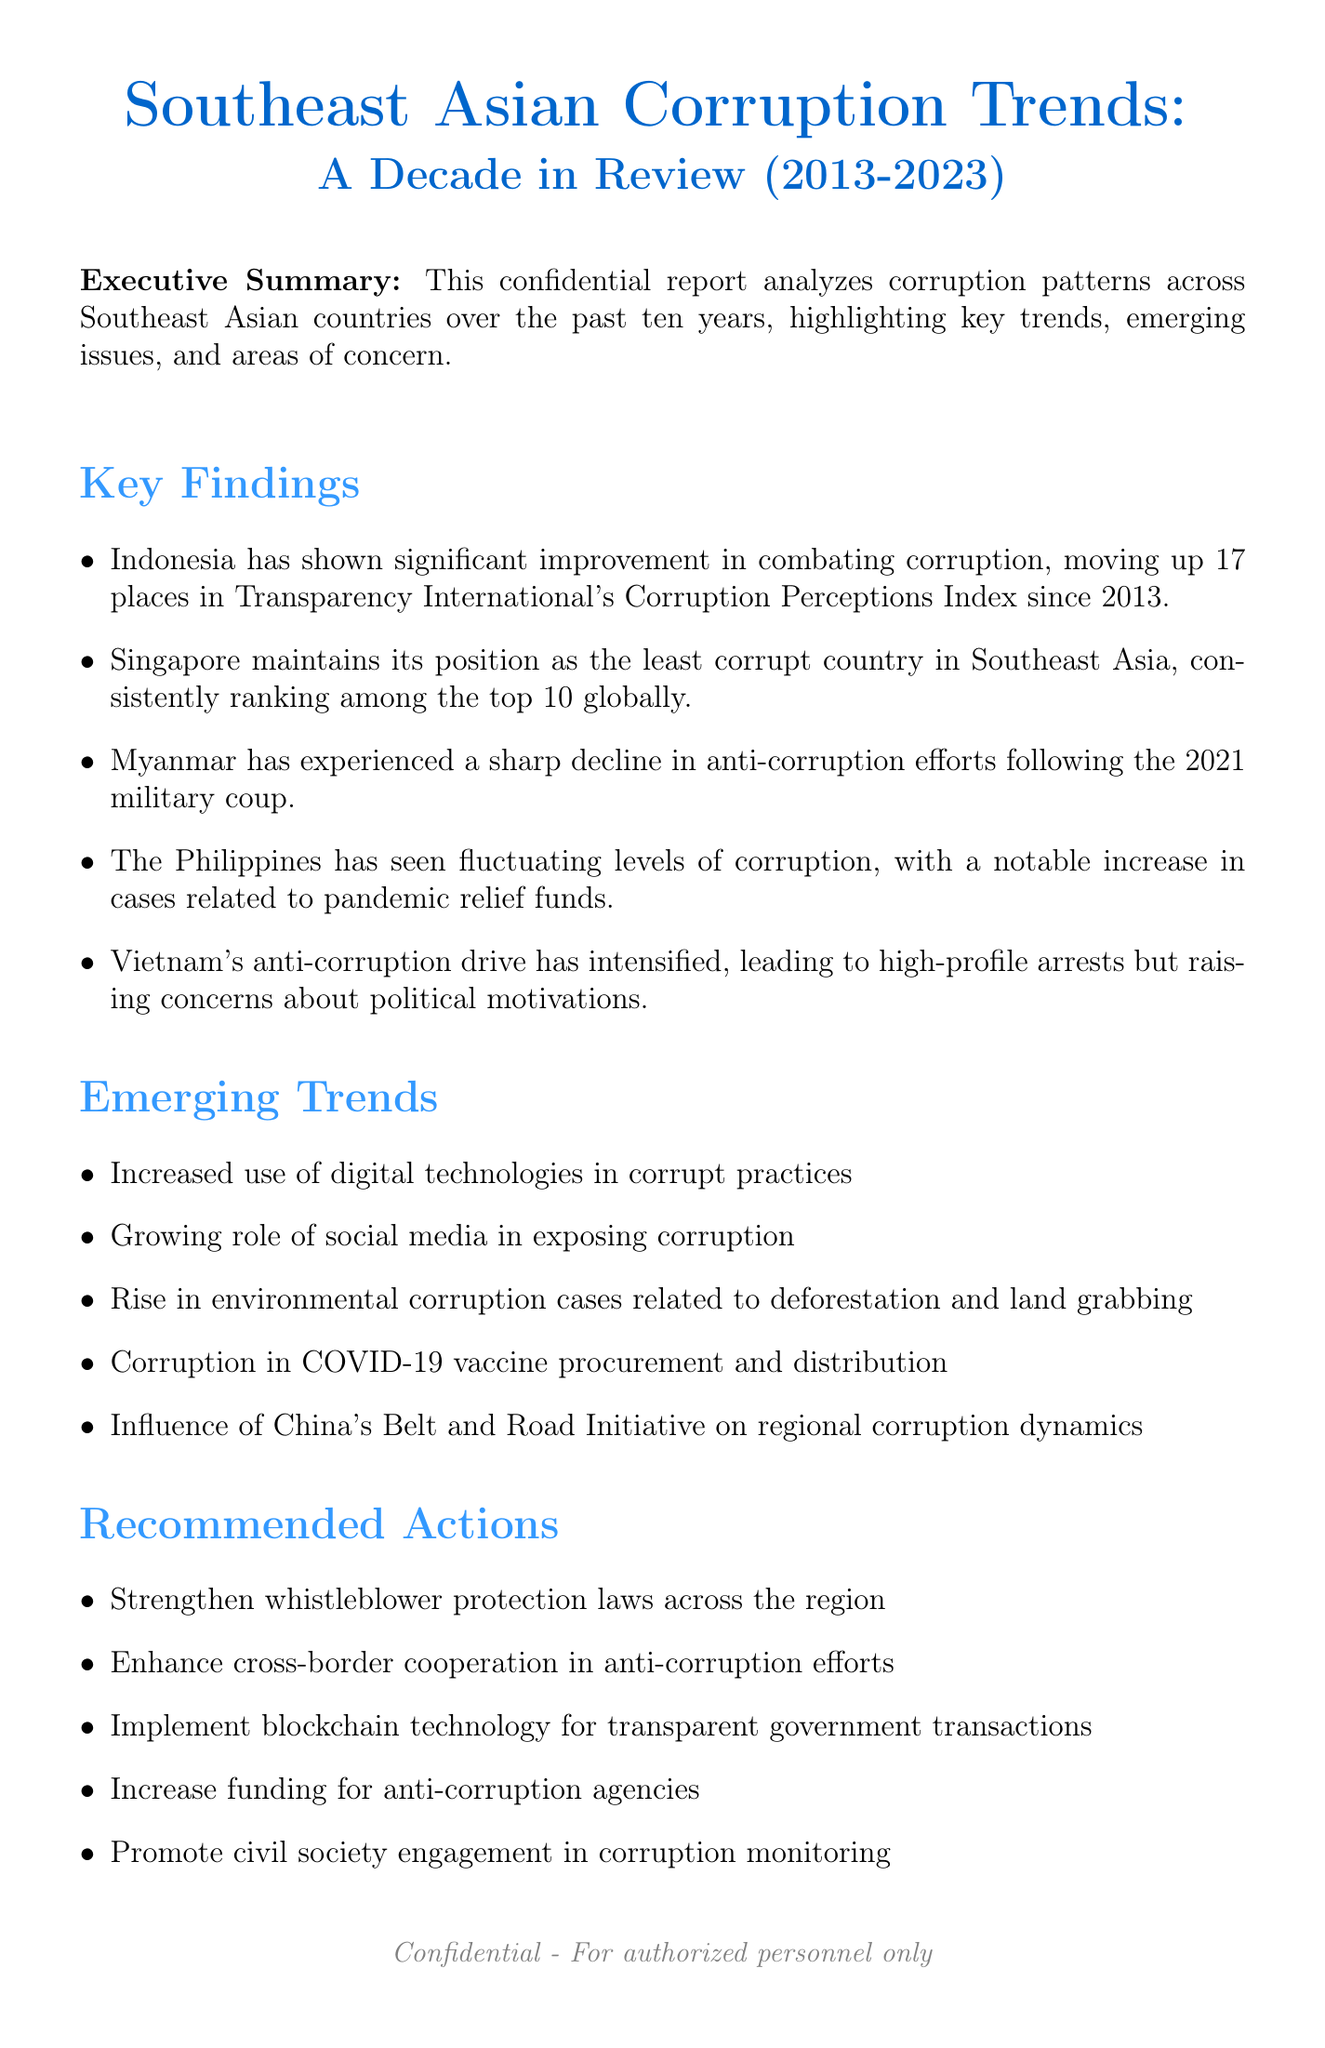What is the title of the report? The title of the report is clearly stated at the beginning and is "Southeast Asian Corruption Trends: A Decade in Review (2013-2023)."
Answer: Southeast Asian Corruption Trends: A Decade in Review (2013-2023) Who is the lead researcher of the report? The lead researcher is mentioned in the authors section as Dr. Astrid Chen.
Answer: Dr. Astrid Chen What significant change occurred in Indonesia's Corruption Perceptions Index ranking? The document states that Indonesia improved its ranking by moving up 17 places in Transparency International's Corruption Perceptions Index since 2013.
Answer: 17 places Which country is noted for being the least corrupt in Southeast Asia? The document highlights Singapore as maintaining its position as the least corrupt country in Southeast Asia.
Answer: Singapore What trend has been observed in Myanmar following the 2021 military coup? The report mentions that Myanmar has experienced a sharp decline in anti-corruption efforts.
Answer: Sharp decline List one recommended action for addressing corruption in the region. The recommended actions are listed, one of which is to "Strengthen whistleblower protection laws across the region."
Answer: Strengthen whistleblower protection laws across the region What is the confidentiality level of the report? The document specifies the confidentiality level as "Restricted - For authorized personnel only."
Answer: Restricted - For authorized personnel only What is one emerging trend related to corruption mentioned in the report? Among various emerging trends, the document includes "Increased use of digital technologies in corrupt practices."
Answer: Increased use of digital technologies in corrupt practices How many countries were analyzed in the report? The countries analyzed in the report are listed, totaling 10 countries.
Answer: 10 countries 